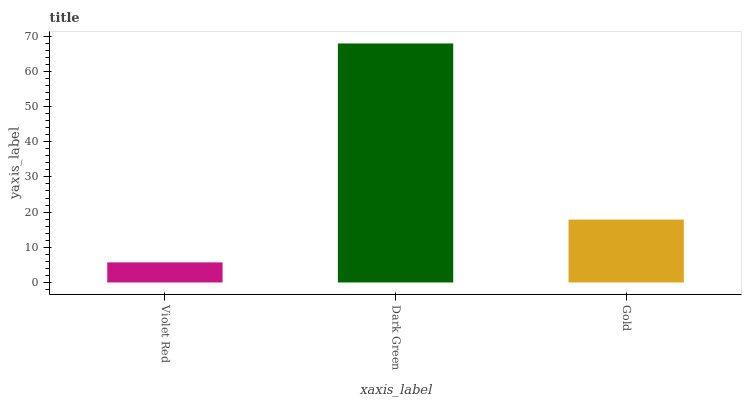Is Gold the minimum?
Answer yes or no. No. Is Gold the maximum?
Answer yes or no. No. Is Dark Green greater than Gold?
Answer yes or no. Yes. Is Gold less than Dark Green?
Answer yes or no. Yes. Is Gold greater than Dark Green?
Answer yes or no. No. Is Dark Green less than Gold?
Answer yes or no. No. Is Gold the high median?
Answer yes or no. Yes. Is Gold the low median?
Answer yes or no. Yes. Is Violet Red the high median?
Answer yes or no. No. Is Violet Red the low median?
Answer yes or no. No. 